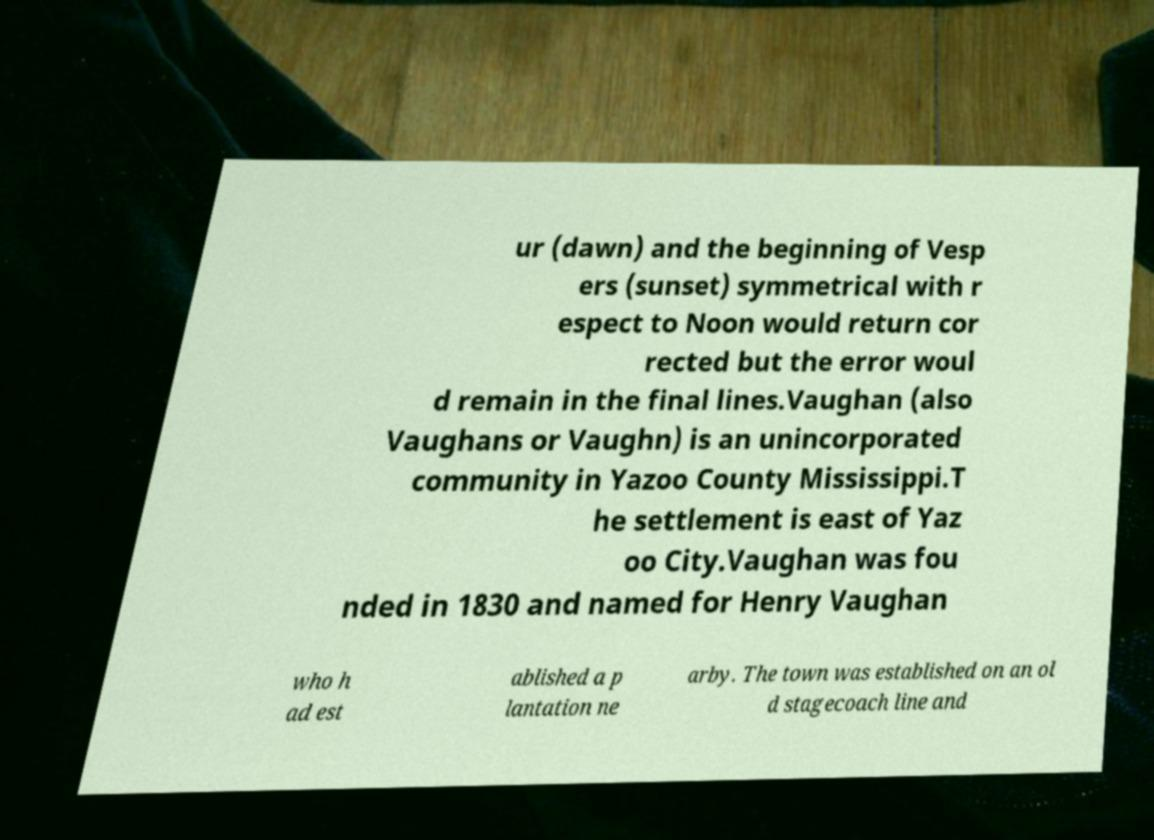There's text embedded in this image that I need extracted. Can you transcribe it verbatim? ur (dawn) and the beginning of Vesp ers (sunset) symmetrical with r espect to Noon would return cor rected but the error woul d remain in the final lines.Vaughan (also Vaughans or Vaughn) is an unincorporated community in Yazoo County Mississippi.T he settlement is east of Yaz oo City.Vaughan was fou nded in 1830 and named for Henry Vaughan who h ad est ablished a p lantation ne arby. The town was established on an ol d stagecoach line and 